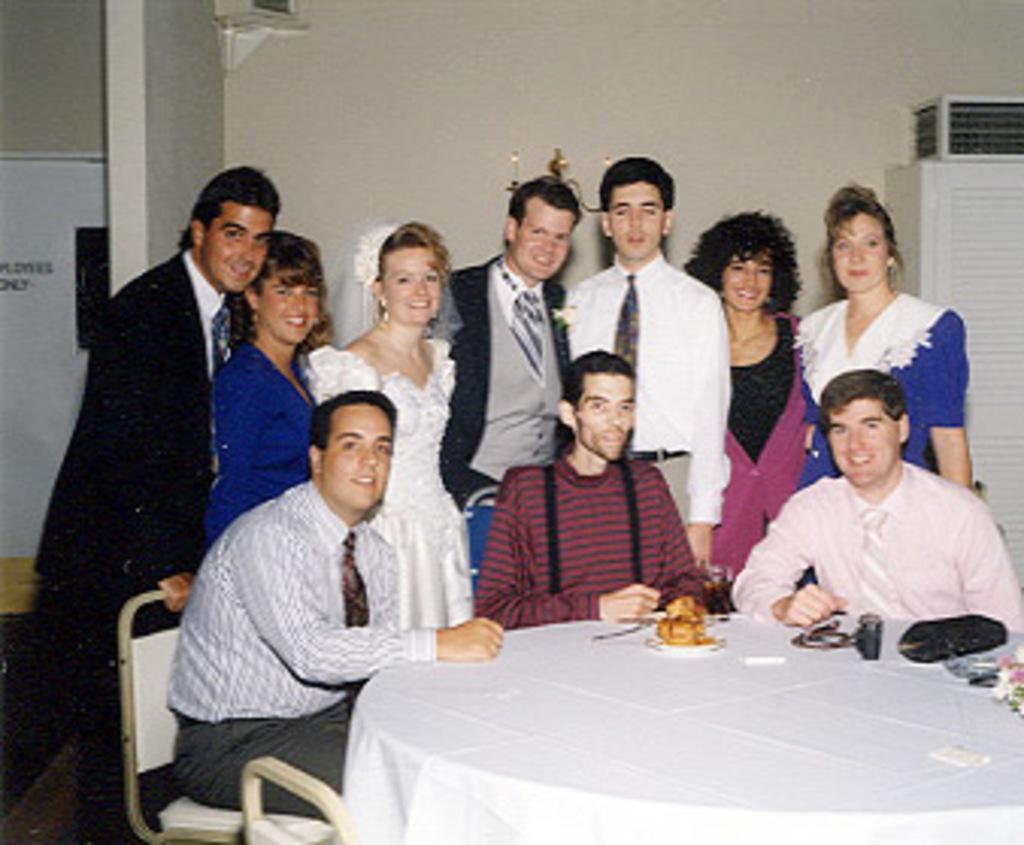Describe this image in one or two sentences. In this picture we can see some people standing and some are sitting on chairs and they all are smiling and in front of them there is table and on table we can see some items and background we can see wall. 